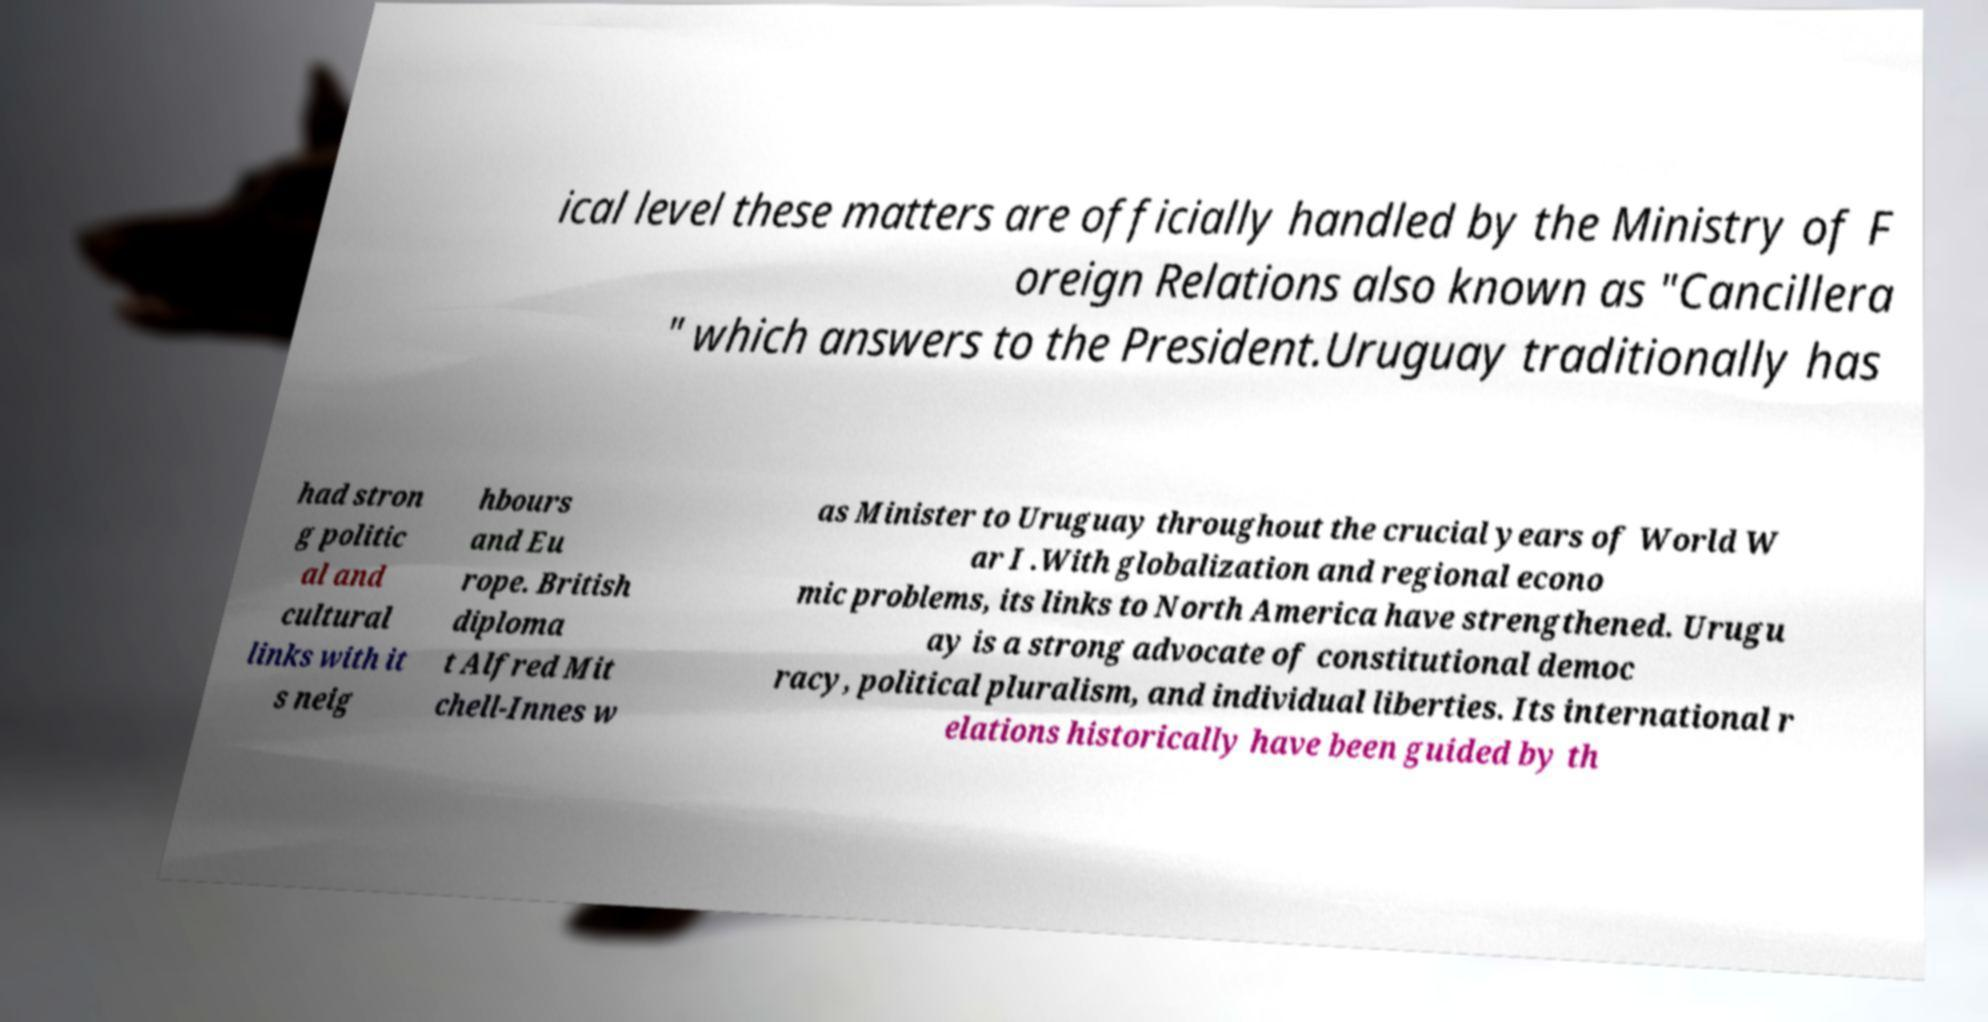Can you accurately transcribe the text from the provided image for me? ical level these matters are officially handled by the Ministry of F oreign Relations also known as "Cancillera " which answers to the President.Uruguay traditionally has had stron g politic al and cultural links with it s neig hbours and Eu rope. British diploma t Alfred Mit chell-Innes w as Minister to Uruguay throughout the crucial years of World W ar I .With globalization and regional econo mic problems, its links to North America have strengthened. Urugu ay is a strong advocate of constitutional democ racy, political pluralism, and individual liberties. Its international r elations historically have been guided by th 